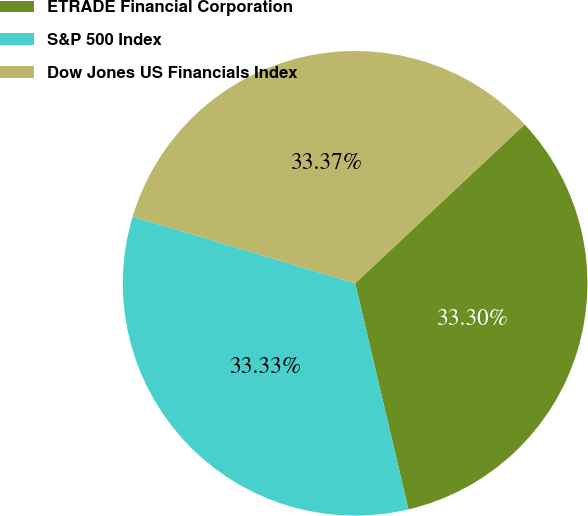Convert chart. <chart><loc_0><loc_0><loc_500><loc_500><pie_chart><fcel>ETRADE Financial Corporation<fcel>S&P 500 Index<fcel>Dow Jones US Financials Index<nl><fcel>33.3%<fcel>33.33%<fcel>33.37%<nl></chart> 